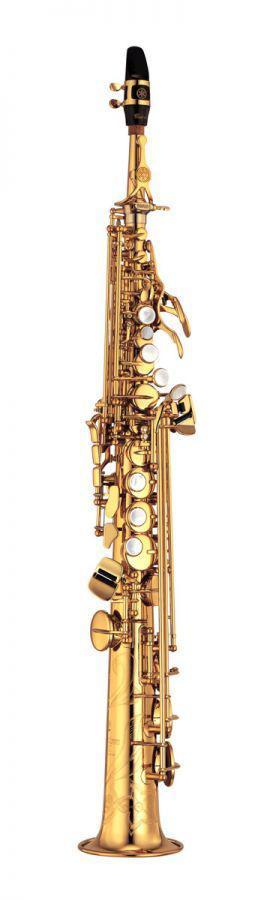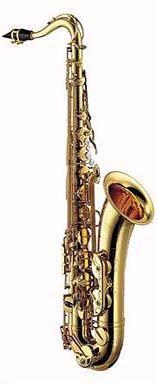The first image is the image on the left, the second image is the image on the right. Examine the images to the left and right. Is the description "Each image shows a saxophone with an upturned bell, and one image features a violet-blue saxophone." accurate? Answer yes or no. No. The first image is the image on the left, the second image is the image on the right. Analyze the images presented: Is the assertion "The left image contains one purple and gold saxophone." valid? Answer yes or no. No. 